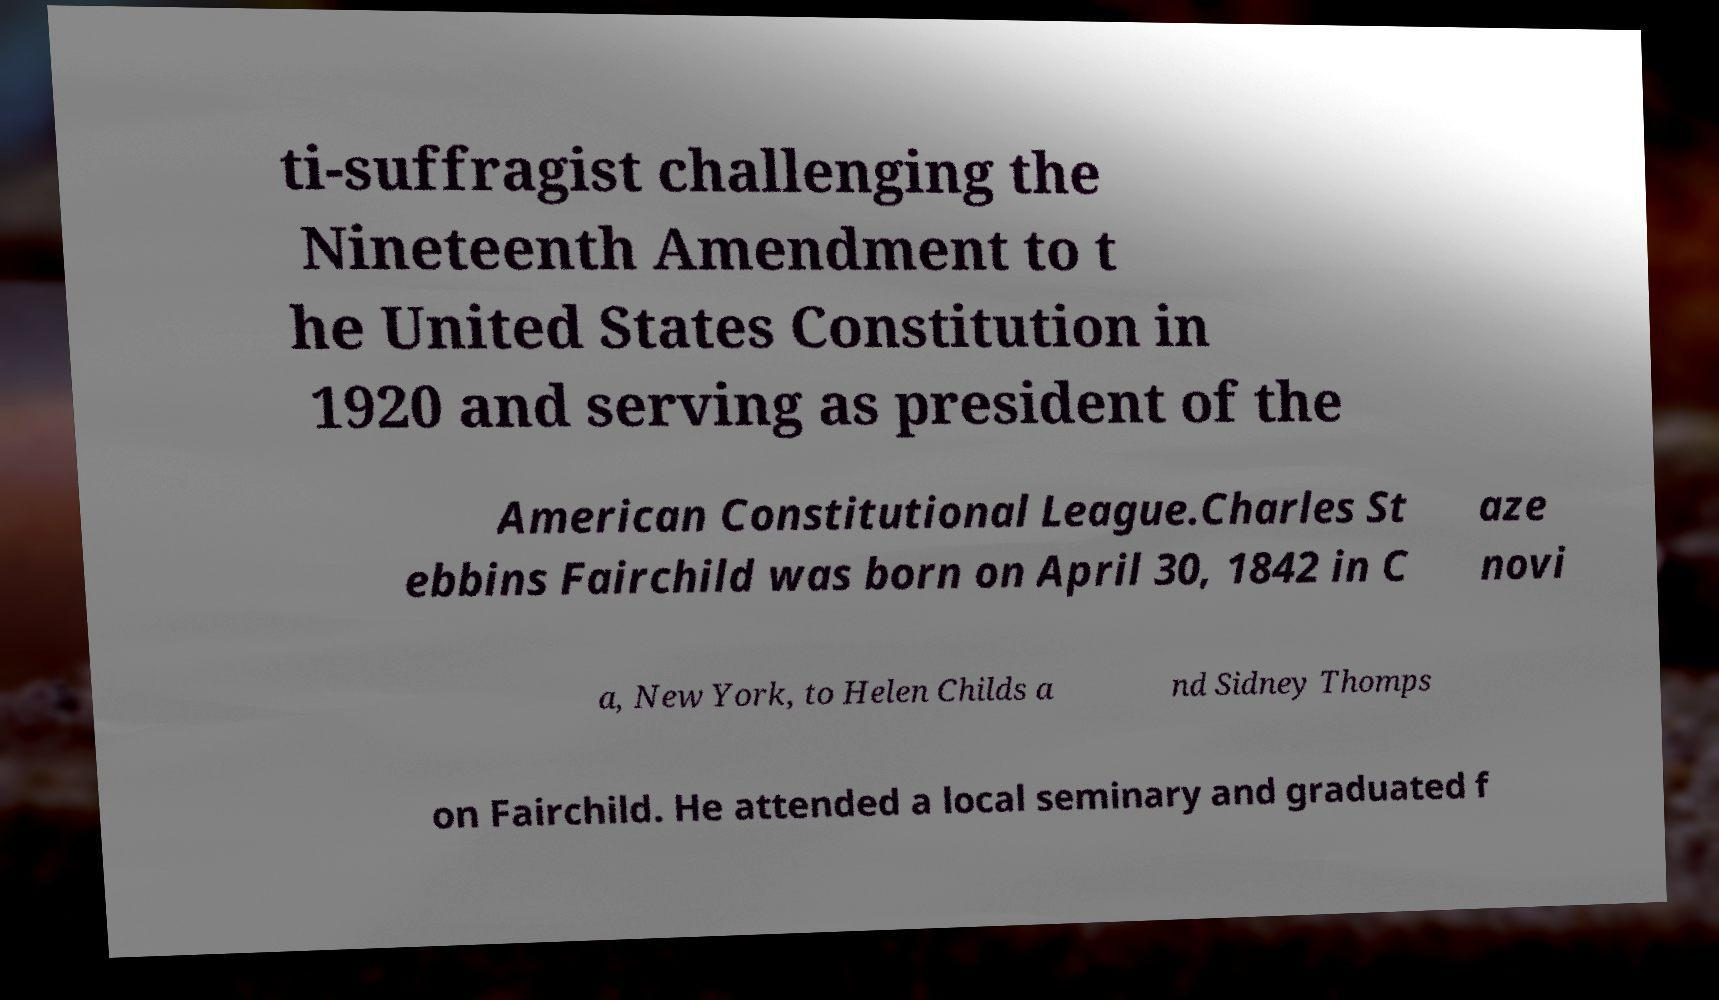Can you accurately transcribe the text from the provided image for me? ti-suffragist challenging the Nineteenth Amendment to t he United States Constitution in 1920 and serving as president of the American Constitutional League.Charles St ebbins Fairchild was born on April 30, 1842 in C aze novi a, New York, to Helen Childs a nd Sidney Thomps on Fairchild. He attended a local seminary and graduated f 